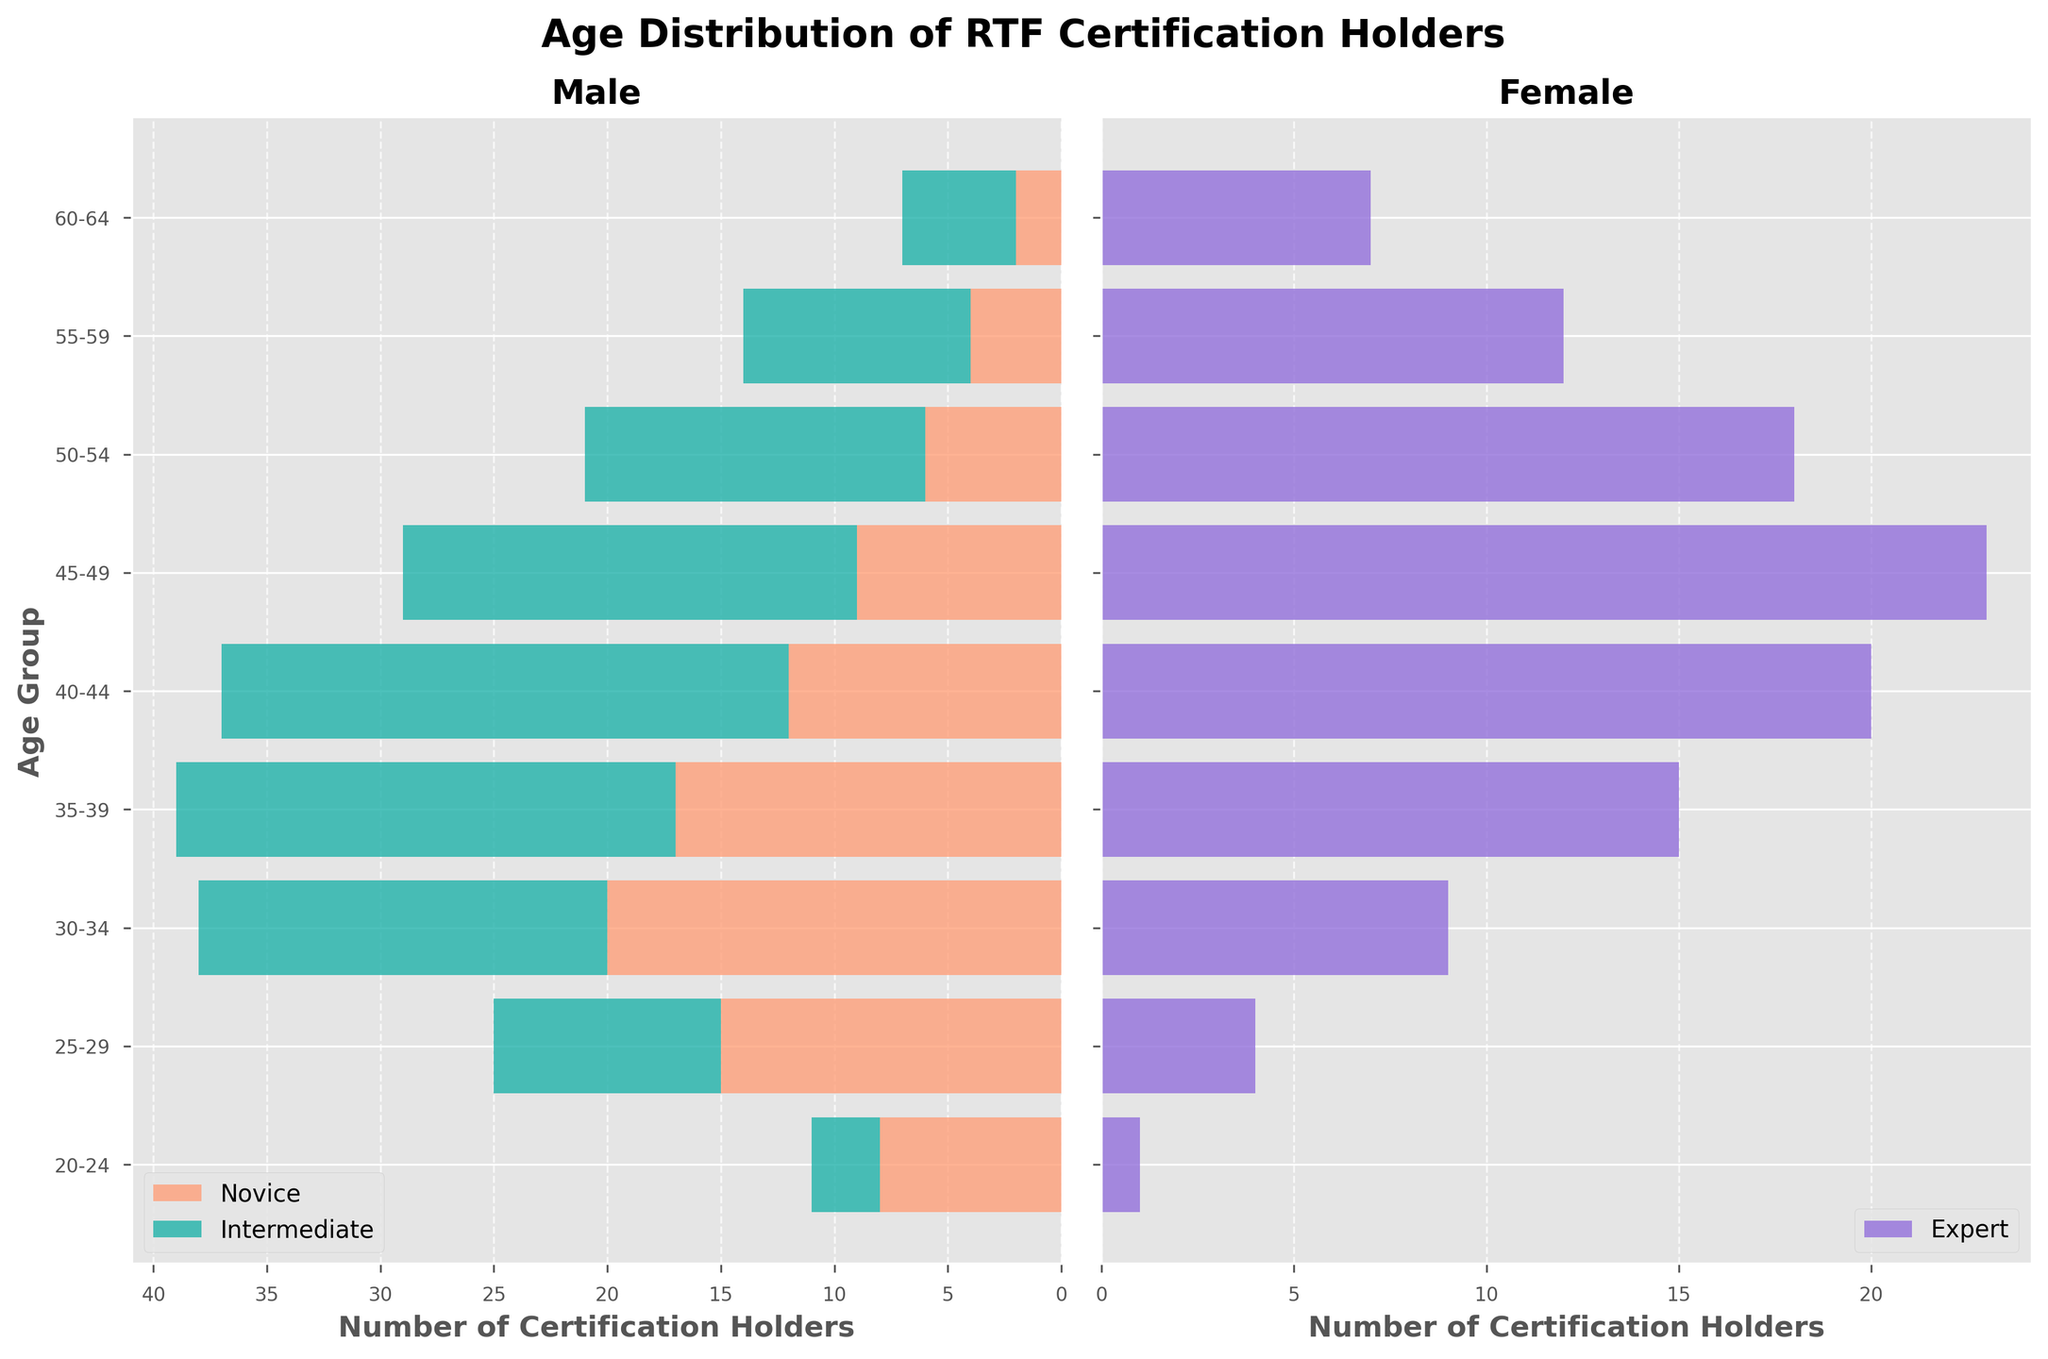What's the title of the figure? The title of the figure is prominently displayed at the top of the chart, indicating the main subject being depicted.
Answer: Age Distribution of RTF Certification Holders What are the age groups shown on the vertical axis? The labels along the vertical axis list all age groups categorized in the data. These are arranged vertically beside the horizontal bars in the chart.
Answer: 20-24, 25-29, 30-34, 35-39, 40-44, 45-49, 50-54, 55-59, 60-64 Which age group has the highest number of novice certification holders? By observing the lengths of the horizontal bars on the left side of the figure (which represents novice certification holders), we identify the longest bar.
Answer: 30-34 How does the number of intermediate certification holders in the 35-39 age group compare to that for novice certification holders within the same group? Inspect both segments for the 35-39 age group on the left side of the chart to see which one is longer. The intermediate segment starts where the novice segment ends.
Answer: Intermediate is longer What's the total number of certification holders in the 40-44 age group? Sum the values for novice, intermediate, and expert certification holders in the 40-44 age group. These values are indicated by the lengths of the respective bars.
Answer: 57 Which age group has the fewest certification holders overall? Add up the numbers for novice, intermediate, and expert certification holders in each age group, then compare totals across age groups to find the minimum.
Answer: 60-64 Which age group exhibits a balanced distribution between novice, intermediate, and expert certification holders? Look for an age group where the segments representing novice, intermediate, and expert are roughly equal in length. Compare these visually across age groups.
Answer: 50-54 How does the number of expert certification holders in the 45-49 age group compare to those in the 50-54 age group? Compare the lengths of the horizontal bars on the right side of the figure for the 45-49 and 50-54 age groups. The longer bar indicates a higher number.
Answer: Higher in 45-49 Is there a trend in the number of certification holders with increasing age? Analyze the lengths of the bars from left to right across different age groups to determine the trend. Note how the bar lengths change with increasing age.
Answer: Generally decreasing What color represents the intermediate certification holders? Identify the color used for the intermediate segment on the left side of the chart in novice and intermediate holder sections.
Answer: Light sea green (teal) 